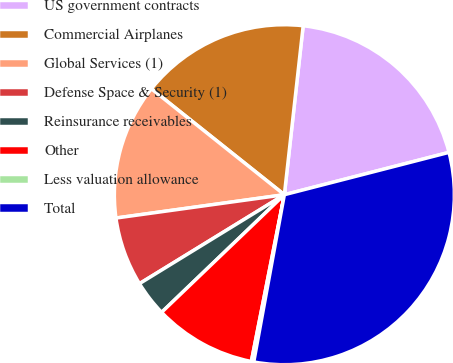<chart> <loc_0><loc_0><loc_500><loc_500><pie_chart><fcel>US government contracts<fcel>Commercial Airplanes<fcel>Global Services (1)<fcel>Defense Space & Security (1)<fcel>Reinsurance receivables<fcel>Other<fcel>Less valuation allowance<fcel>Total<nl><fcel>19.23%<fcel>16.06%<fcel>12.9%<fcel>6.57%<fcel>3.4%<fcel>9.73%<fcel>0.23%<fcel>31.89%<nl></chart> 